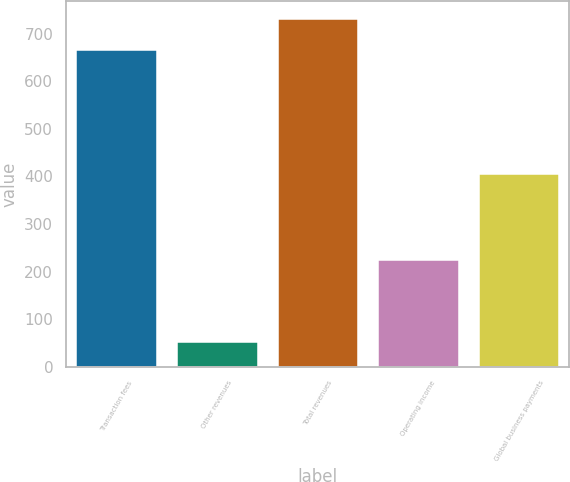Convert chart to OTSL. <chart><loc_0><loc_0><loc_500><loc_500><bar_chart><fcel>Transaction fees<fcel>Other revenues<fcel>Total revenues<fcel>Operating income<fcel>Global business payments<nl><fcel>665.5<fcel>52.4<fcel>732.25<fcel>223.7<fcel>404.5<nl></chart> 